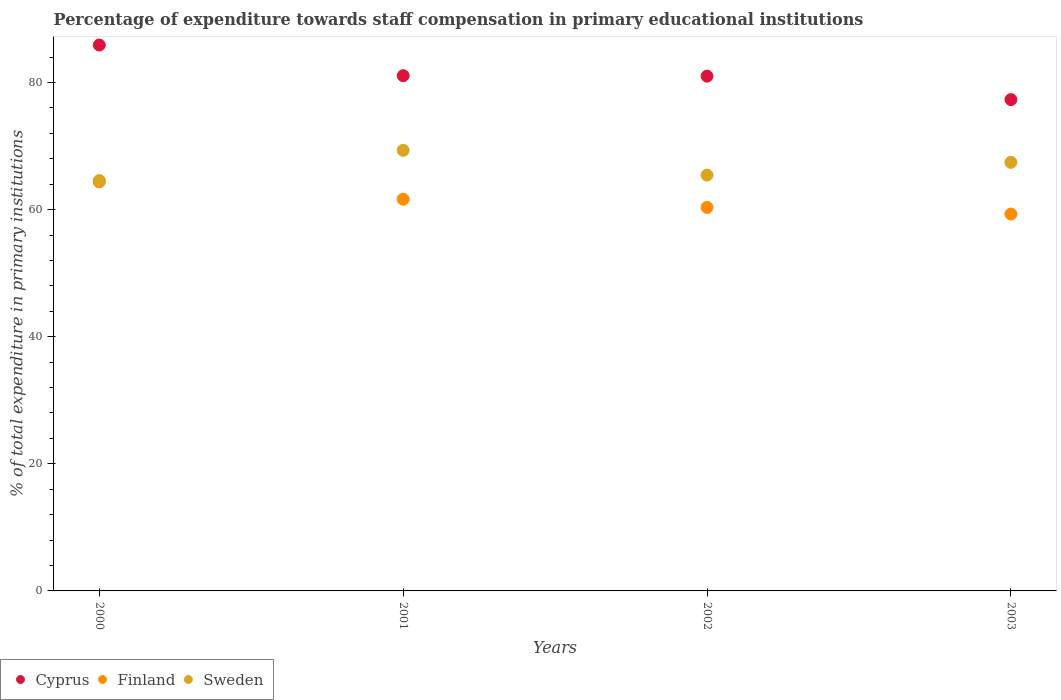How many different coloured dotlines are there?
Offer a very short reply. 3. What is the percentage of expenditure towards staff compensation in Sweden in 2001?
Your response must be concise. 69.32. Across all years, what is the maximum percentage of expenditure towards staff compensation in Finland?
Ensure brevity in your answer.  64.36. Across all years, what is the minimum percentage of expenditure towards staff compensation in Cyprus?
Keep it short and to the point. 77.3. In which year was the percentage of expenditure towards staff compensation in Cyprus maximum?
Keep it short and to the point. 2000. In which year was the percentage of expenditure towards staff compensation in Cyprus minimum?
Make the answer very short. 2003. What is the total percentage of expenditure towards staff compensation in Finland in the graph?
Your answer should be very brief. 245.63. What is the difference between the percentage of expenditure towards staff compensation in Sweden in 2000 and that in 2001?
Give a very brief answer. -4.75. What is the difference between the percentage of expenditure towards staff compensation in Cyprus in 2002 and the percentage of expenditure towards staff compensation in Finland in 2003?
Provide a short and direct response. 21.69. What is the average percentage of expenditure towards staff compensation in Sweden per year?
Ensure brevity in your answer.  66.68. In the year 2003, what is the difference between the percentage of expenditure towards staff compensation in Finland and percentage of expenditure towards staff compensation in Sweden?
Keep it short and to the point. -8.14. What is the ratio of the percentage of expenditure towards staff compensation in Cyprus in 2000 to that in 2001?
Make the answer very short. 1.06. Is the percentage of expenditure towards staff compensation in Finland in 2001 less than that in 2003?
Your response must be concise. No. Is the difference between the percentage of expenditure towards staff compensation in Finland in 2001 and 2003 greater than the difference between the percentage of expenditure towards staff compensation in Sweden in 2001 and 2003?
Provide a succinct answer. Yes. What is the difference between the highest and the second highest percentage of expenditure towards staff compensation in Sweden?
Give a very brief answer. 1.88. What is the difference between the highest and the lowest percentage of expenditure towards staff compensation in Sweden?
Make the answer very short. 4.75. Is it the case that in every year, the sum of the percentage of expenditure towards staff compensation in Cyprus and percentage of expenditure towards staff compensation in Finland  is greater than the percentage of expenditure towards staff compensation in Sweden?
Give a very brief answer. Yes. Does the percentage of expenditure towards staff compensation in Sweden monotonically increase over the years?
Give a very brief answer. No. What is the difference between two consecutive major ticks on the Y-axis?
Offer a very short reply. 20. Are the values on the major ticks of Y-axis written in scientific E-notation?
Give a very brief answer. No. Does the graph contain any zero values?
Ensure brevity in your answer.  No. Where does the legend appear in the graph?
Make the answer very short. Bottom left. What is the title of the graph?
Your answer should be very brief. Percentage of expenditure towards staff compensation in primary educational institutions. Does "Mauritius" appear as one of the legend labels in the graph?
Your answer should be very brief. No. What is the label or title of the Y-axis?
Offer a terse response. % of total expenditure in primary institutions. What is the % of total expenditure in primary institutions of Cyprus in 2000?
Your response must be concise. 85.89. What is the % of total expenditure in primary institutions of Finland in 2000?
Keep it short and to the point. 64.36. What is the % of total expenditure in primary institutions in Sweden in 2000?
Provide a short and direct response. 64.57. What is the % of total expenditure in primary institutions in Cyprus in 2001?
Provide a short and direct response. 81.06. What is the % of total expenditure in primary institutions in Finland in 2001?
Keep it short and to the point. 61.63. What is the % of total expenditure in primary institutions in Sweden in 2001?
Ensure brevity in your answer.  69.32. What is the % of total expenditure in primary institutions in Cyprus in 2002?
Make the answer very short. 80.99. What is the % of total expenditure in primary institutions in Finland in 2002?
Keep it short and to the point. 60.34. What is the % of total expenditure in primary institutions of Sweden in 2002?
Your answer should be compact. 65.42. What is the % of total expenditure in primary institutions of Cyprus in 2003?
Your response must be concise. 77.3. What is the % of total expenditure in primary institutions of Finland in 2003?
Ensure brevity in your answer.  59.3. What is the % of total expenditure in primary institutions in Sweden in 2003?
Provide a short and direct response. 67.43. Across all years, what is the maximum % of total expenditure in primary institutions of Cyprus?
Give a very brief answer. 85.89. Across all years, what is the maximum % of total expenditure in primary institutions of Finland?
Your response must be concise. 64.36. Across all years, what is the maximum % of total expenditure in primary institutions in Sweden?
Ensure brevity in your answer.  69.32. Across all years, what is the minimum % of total expenditure in primary institutions in Cyprus?
Ensure brevity in your answer.  77.3. Across all years, what is the minimum % of total expenditure in primary institutions of Finland?
Your answer should be compact. 59.3. Across all years, what is the minimum % of total expenditure in primary institutions of Sweden?
Offer a terse response. 64.57. What is the total % of total expenditure in primary institutions of Cyprus in the graph?
Provide a short and direct response. 325.25. What is the total % of total expenditure in primary institutions of Finland in the graph?
Provide a succinct answer. 245.63. What is the total % of total expenditure in primary institutions of Sweden in the graph?
Your response must be concise. 266.74. What is the difference between the % of total expenditure in primary institutions in Cyprus in 2000 and that in 2001?
Your response must be concise. 4.83. What is the difference between the % of total expenditure in primary institutions of Finland in 2000 and that in 2001?
Offer a terse response. 2.73. What is the difference between the % of total expenditure in primary institutions of Sweden in 2000 and that in 2001?
Make the answer very short. -4.75. What is the difference between the % of total expenditure in primary institutions in Cyprus in 2000 and that in 2002?
Your answer should be compact. 4.9. What is the difference between the % of total expenditure in primary institutions in Finland in 2000 and that in 2002?
Offer a very short reply. 4.02. What is the difference between the % of total expenditure in primary institutions of Sweden in 2000 and that in 2002?
Provide a succinct answer. -0.86. What is the difference between the % of total expenditure in primary institutions of Cyprus in 2000 and that in 2003?
Your answer should be very brief. 8.59. What is the difference between the % of total expenditure in primary institutions of Finland in 2000 and that in 2003?
Provide a short and direct response. 5.06. What is the difference between the % of total expenditure in primary institutions in Sweden in 2000 and that in 2003?
Offer a terse response. -2.87. What is the difference between the % of total expenditure in primary institutions of Cyprus in 2001 and that in 2002?
Provide a succinct answer. 0.07. What is the difference between the % of total expenditure in primary institutions of Finland in 2001 and that in 2002?
Give a very brief answer. 1.29. What is the difference between the % of total expenditure in primary institutions of Sweden in 2001 and that in 2002?
Keep it short and to the point. 3.89. What is the difference between the % of total expenditure in primary institutions of Cyprus in 2001 and that in 2003?
Offer a terse response. 3.76. What is the difference between the % of total expenditure in primary institutions of Finland in 2001 and that in 2003?
Provide a succinct answer. 2.33. What is the difference between the % of total expenditure in primary institutions of Sweden in 2001 and that in 2003?
Provide a short and direct response. 1.88. What is the difference between the % of total expenditure in primary institutions of Cyprus in 2002 and that in 2003?
Your answer should be compact. 3.69. What is the difference between the % of total expenditure in primary institutions in Finland in 2002 and that in 2003?
Offer a very short reply. 1.04. What is the difference between the % of total expenditure in primary institutions of Sweden in 2002 and that in 2003?
Provide a short and direct response. -2.01. What is the difference between the % of total expenditure in primary institutions in Cyprus in 2000 and the % of total expenditure in primary institutions in Finland in 2001?
Offer a very short reply. 24.26. What is the difference between the % of total expenditure in primary institutions of Cyprus in 2000 and the % of total expenditure in primary institutions of Sweden in 2001?
Provide a succinct answer. 16.57. What is the difference between the % of total expenditure in primary institutions of Finland in 2000 and the % of total expenditure in primary institutions of Sweden in 2001?
Provide a succinct answer. -4.96. What is the difference between the % of total expenditure in primary institutions of Cyprus in 2000 and the % of total expenditure in primary institutions of Finland in 2002?
Offer a very short reply. 25.55. What is the difference between the % of total expenditure in primary institutions of Cyprus in 2000 and the % of total expenditure in primary institutions of Sweden in 2002?
Offer a terse response. 20.47. What is the difference between the % of total expenditure in primary institutions in Finland in 2000 and the % of total expenditure in primary institutions in Sweden in 2002?
Provide a short and direct response. -1.06. What is the difference between the % of total expenditure in primary institutions of Cyprus in 2000 and the % of total expenditure in primary institutions of Finland in 2003?
Ensure brevity in your answer.  26.59. What is the difference between the % of total expenditure in primary institutions of Cyprus in 2000 and the % of total expenditure in primary institutions of Sweden in 2003?
Provide a succinct answer. 18.46. What is the difference between the % of total expenditure in primary institutions of Finland in 2000 and the % of total expenditure in primary institutions of Sweden in 2003?
Provide a short and direct response. -3.07. What is the difference between the % of total expenditure in primary institutions in Cyprus in 2001 and the % of total expenditure in primary institutions in Finland in 2002?
Give a very brief answer. 20.73. What is the difference between the % of total expenditure in primary institutions of Cyprus in 2001 and the % of total expenditure in primary institutions of Sweden in 2002?
Offer a terse response. 15.64. What is the difference between the % of total expenditure in primary institutions in Finland in 2001 and the % of total expenditure in primary institutions in Sweden in 2002?
Provide a short and direct response. -3.79. What is the difference between the % of total expenditure in primary institutions of Cyprus in 2001 and the % of total expenditure in primary institutions of Finland in 2003?
Provide a short and direct response. 21.77. What is the difference between the % of total expenditure in primary institutions in Cyprus in 2001 and the % of total expenditure in primary institutions in Sweden in 2003?
Offer a terse response. 13.63. What is the difference between the % of total expenditure in primary institutions of Finland in 2001 and the % of total expenditure in primary institutions of Sweden in 2003?
Make the answer very short. -5.8. What is the difference between the % of total expenditure in primary institutions in Cyprus in 2002 and the % of total expenditure in primary institutions in Finland in 2003?
Make the answer very short. 21.69. What is the difference between the % of total expenditure in primary institutions in Cyprus in 2002 and the % of total expenditure in primary institutions in Sweden in 2003?
Provide a succinct answer. 13.56. What is the difference between the % of total expenditure in primary institutions in Finland in 2002 and the % of total expenditure in primary institutions in Sweden in 2003?
Offer a very short reply. -7.1. What is the average % of total expenditure in primary institutions in Cyprus per year?
Ensure brevity in your answer.  81.31. What is the average % of total expenditure in primary institutions of Finland per year?
Provide a short and direct response. 61.41. What is the average % of total expenditure in primary institutions of Sweden per year?
Provide a short and direct response. 66.68. In the year 2000, what is the difference between the % of total expenditure in primary institutions in Cyprus and % of total expenditure in primary institutions in Finland?
Your answer should be very brief. 21.53. In the year 2000, what is the difference between the % of total expenditure in primary institutions of Cyprus and % of total expenditure in primary institutions of Sweden?
Give a very brief answer. 21.32. In the year 2000, what is the difference between the % of total expenditure in primary institutions in Finland and % of total expenditure in primary institutions in Sweden?
Offer a very short reply. -0.21. In the year 2001, what is the difference between the % of total expenditure in primary institutions in Cyprus and % of total expenditure in primary institutions in Finland?
Ensure brevity in your answer.  19.43. In the year 2001, what is the difference between the % of total expenditure in primary institutions of Cyprus and % of total expenditure in primary institutions of Sweden?
Provide a succinct answer. 11.75. In the year 2001, what is the difference between the % of total expenditure in primary institutions in Finland and % of total expenditure in primary institutions in Sweden?
Provide a succinct answer. -7.69. In the year 2002, what is the difference between the % of total expenditure in primary institutions of Cyprus and % of total expenditure in primary institutions of Finland?
Provide a short and direct response. 20.65. In the year 2002, what is the difference between the % of total expenditure in primary institutions of Cyprus and % of total expenditure in primary institutions of Sweden?
Keep it short and to the point. 15.57. In the year 2002, what is the difference between the % of total expenditure in primary institutions in Finland and % of total expenditure in primary institutions in Sweden?
Make the answer very short. -5.09. In the year 2003, what is the difference between the % of total expenditure in primary institutions in Cyprus and % of total expenditure in primary institutions in Finland?
Your answer should be compact. 18.01. In the year 2003, what is the difference between the % of total expenditure in primary institutions in Cyprus and % of total expenditure in primary institutions in Sweden?
Make the answer very short. 9.87. In the year 2003, what is the difference between the % of total expenditure in primary institutions of Finland and % of total expenditure in primary institutions of Sweden?
Provide a succinct answer. -8.14. What is the ratio of the % of total expenditure in primary institutions of Cyprus in 2000 to that in 2001?
Offer a terse response. 1.06. What is the ratio of the % of total expenditure in primary institutions of Finland in 2000 to that in 2001?
Give a very brief answer. 1.04. What is the ratio of the % of total expenditure in primary institutions of Sweden in 2000 to that in 2001?
Ensure brevity in your answer.  0.93. What is the ratio of the % of total expenditure in primary institutions of Cyprus in 2000 to that in 2002?
Provide a succinct answer. 1.06. What is the ratio of the % of total expenditure in primary institutions in Finland in 2000 to that in 2002?
Your answer should be very brief. 1.07. What is the ratio of the % of total expenditure in primary institutions of Sweden in 2000 to that in 2002?
Offer a terse response. 0.99. What is the ratio of the % of total expenditure in primary institutions in Cyprus in 2000 to that in 2003?
Offer a terse response. 1.11. What is the ratio of the % of total expenditure in primary institutions in Finland in 2000 to that in 2003?
Provide a short and direct response. 1.09. What is the ratio of the % of total expenditure in primary institutions of Sweden in 2000 to that in 2003?
Your answer should be compact. 0.96. What is the ratio of the % of total expenditure in primary institutions of Finland in 2001 to that in 2002?
Keep it short and to the point. 1.02. What is the ratio of the % of total expenditure in primary institutions of Sweden in 2001 to that in 2002?
Offer a very short reply. 1.06. What is the ratio of the % of total expenditure in primary institutions in Cyprus in 2001 to that in 2003?
Your response must be concise. 1.05. What is the ratio of the % of total expenditure in primary institutions in Finland in 2001 to that in 2003?
Give a very brief answer. 1.04. What is the ratio of the % of total expenditure in primary institutions of Sweden in 2001 to that in 2003?
Provide a succinct answer. 1.03. What is the ratio of the % of total expenditure in primary institutions in Cyprus in 2002 to that in 2003?
Keep it short and to the point. 1.05. What is the ratio of the % of total expenditure in primary institutions of Finland in 2002 to that in 2003?
Provide a short and direct response. 1.02. What is the ratio of the % of total expenditure in primary institutions in Sweden in 2002 to that in 2003?
Ensure brevity in your answer.  0.97. What is the difference between the highest and the second highest % of total expenditure in primary institutions in Cyprus?
Provide a short and direct response. 4.83. What is the difference between the highest and the second highest % of total expenditure in primary institutions in Finland?
Your answer should be compact. 2.73. What is the difference between the highest and the second highest % of total expenditure in primary institutions in Sweden?
Your response must be concise. 1.88. What is the difference between the highest and the lowest % of total expenditure in primary institutions of Cyprus?
Your answer should be very brief. 8.59. What is the difference between the highest and the lowest % of total expenditure in primary institutions of Finland?
Offer a very short reply. 5.06. What is the difference between the highest and the lowest % of total expenditure in primary institutions in Sweden?
Offer a terse response. 4.75. 